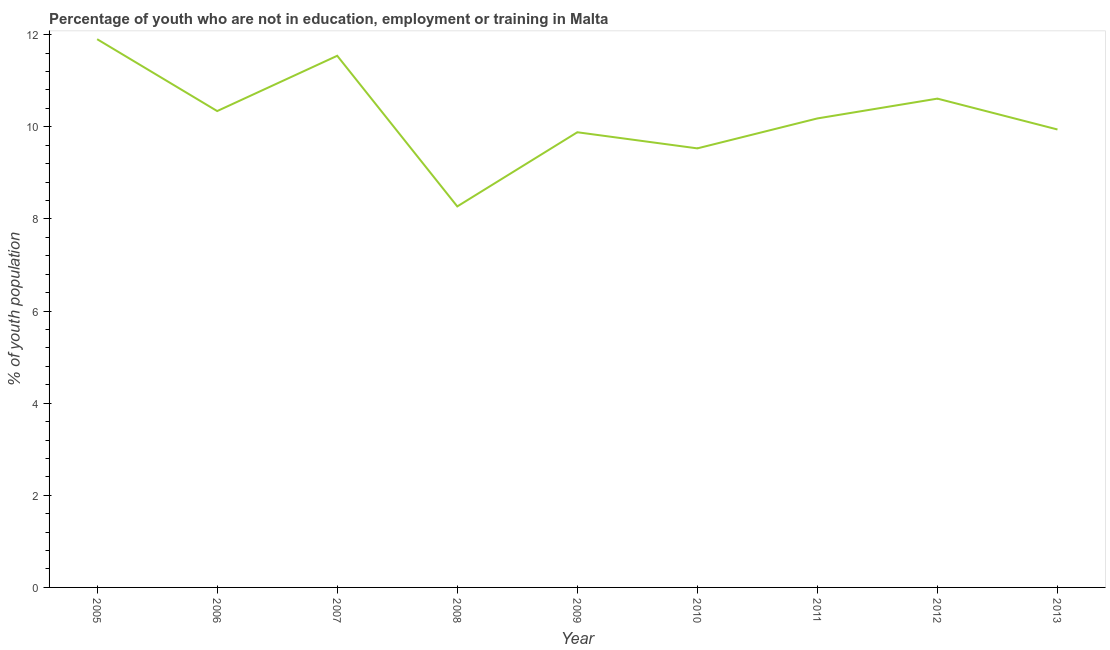What is the unemployed youth population in 2010?
Ensure brevity in your answer.  9.53. Across all years, what is the maximum unemployed youth population?
Your answer should be compact. 11.9. Across all years, what is the minimum unemployed youth population?
Your answer should be compact. 8.27. In which year was the unemployed youth population maximum?
Offer a very short reply. 2005. What is the sum of the unemployed youth population?
Make the answer very short. 92.19. What is the difference between the unemployed youth population in 2006 and 2010?
Provide a short and direct response. 0.81. What is the average unemployed youth population per year?
Your response must be concise. 10.24. What is the median unemployed youth population?
Provide a succinct answer. 10.18. In how many years, is the unemployed youth population greater than 8.8 %?
Your answer should be compact. 8. What is the ratio of the unemployed youth population in 2008 to that in 2013?
Give a very brief answer. 0.83. What is the difference between the highest and the second highest unemployed youth population?
Give a very brief answer. 0.36. Is the sum of the unemployed youth population in 2005 and 2011 greater than the maximum unemployed youth population across all years?
Offer a terse response. Yes. What is the difference between the highest and the lowest unemployed youth population?
Your answer should be compact. 3.63. In how many years, is the unemployed youth population greater than the average unemployed youth population taken over all years?
Provide a succinct answer. 4. Are the values on the major ticks of Y-axis written in scientific E-notation?
Ensure brevity in your answer.  No. Does the graph contain any zero values?
Provide a short and direct response. No. Does the graph contain grids?
Your response must be concise. No. What is the title of the graph?
Your response must be concise. Percentage of youth who are not in education, employment or training in Malta. What is the label or title of the Y-axis?
Your answer should be very brief. % of youth population. What is the % of youth population in 2005?
Provide a short and direct response. 11.9. What is the % of youth population of 2006?
Offer a very short reply. 10.34. What is the % of youth population of 2007?
Ensure brevity in your answer.  11.54. What is the % of youth population of 2008?
Ensure brevity in your answer.  8.27. What is the % of youth population in 2009?
Your answer should be compact. 9.88. What is the % of youth population in 2010?
Give a very brief answer. 9.53. What is the % of youth population of 2011?
Your answer should be compact. 10.18. What is the % of youth population in 2012?
Keep it short and to the point. 10.61. What is the % of youth population in 2013?
Provide a short and direct response. 9.94. What is the difference between the % of youth population in 2005 and 2006?
Keep it short and to the point. 1.56. What is the difference between the % of youth population in 2005 and 2007?
Your answer should be very brief. 0.36. What is the difference between the % of youth population in 2005 and 2008?
Give a very brief answer. 3.63. What is the difference between the % of youth population in 2005 and 2009?
Offer a terse response. 2.02. What is the difference between the % of youth population in 2005 and 2010?
Ensure brevity in your answer.  2.37. What is the difference between the % of youth population in 2005 and 2011?
Offer a very short reply. 1.72. What is the difference between the % of youth population in 2005 and 2012?
Offer a terse response. 1.29. What is the difference between the % of youth population in 2005 and 2013?
Offer a terse response. 1.96. What is the difference between the % of youth population in 2006 and 2007?
Keep it short and to the point. -1.2. What is the difference between the % of youth population in 2006 and 2008?
Give a very brief answer. 2.07. What is the difference between the % of youth population in 2006 and 2009?
Keep it short and to the point. 0.46. What is the difference between the % of youth population in 2006 and 2010?
Offer a terse response. 0.81. What is the difference between the % of youth population in 2006 and 2011?
Offer a terse response. 0.16. What is the difference between the % of youth population in 2006 and 2012?
Give a very brief answer. -0.27. What is the difference between the % of youth population in 2006 and 2013?
Offer a very short reply. 0.4. What is the difference between the % of youth population in 2007 and 2008?
Your response must be concise. 3.27. What is the difference between the % of youth population in 2007 and 2009?
Provide a short and direct response. 1.66. What is the difference between the % of youth population in 2007 and 2010?
Provide a short and direct response. 2.01. What is the difference between the % of youth population in 2007 and 2011?
Your answer should be compact. 1.36. What is the difference between the % of youth population in 2008 and 2009?
Make the answer very short. -1.61. What is the difference between the % of youth population in 2008 and 2010?
Your response must be concise. -1.26. What is the difference between the % of youth population in 2008 and 2011?
Offer a terse response. -1.91. What is the difference between the % of youth population in 2008 and 2012?
Provide a succinct answer. -2.34. What is the difference between the % of youth population in 2008 and 2013?
Your answer should be very brief. -1.67. What is the difference between the % of youth population in 2009 and 2010?
Offer a terse response. 0.35. What is the difference between the % of youth population in 2009 and 2011?
Provide a succinct answer. -0.3. What is the difference between the % of youth population in 2009 and 2012?
Ensure brevity in your answer.  -0.73. What is the difference between the % of youth population in 2009 and 2013?
Ensure brevity in your answer.  -0.06. What is the difference between the % of youth population in 2010 and 2011?
Make the answer very short. -0.65. What is the difference between the % of youth population in 2010 and 2012?
Make the answer very short. -1.08. What is the difference between the % of youth population in 2010 and 2013?
Provide a succinct answer. -0.41. What is the difference between the % of youth population in 2011 and 2012?
Keep it short and to the point. -0.43. What is the difference between the % of youth population in 2011 and 2013?
Your answer should be very brief. 0.24. What is the difference between the % of youth population in 2012 and 2013?
Provide a short and direct response. 0.67. What is the ratio of the % of youth population in 2005 to that in 2006?
Offer a very short reply. 1.15. What is the ratio of the % of youth population in 2005 to that in 2007?
Your response must be concise. 1.03. What is the ratio of the % of youth population in 2005 to that in 2008?
Provide a succinct answer. 1.44. What is the ratio of the % of youth population in 2005 to that in 2009?
Offer a terse response. 1.2. What is the ratio of the % of youth population in 2005 to that in 2010?
Provide a short and direct response. 1.25. What is the ratio of the % of youth population in 2005 to that in 2011?
Your answer should be very brief. 1.17. What is the ratio of the % of youth population in 2005 to that in 2012?
Ensure brevity in your answer.  1.12. What is the ratio of the % of youth population in 2005 to that in 2013?
Offer a terse response. 1.2. What is the ratio of the % of youth population in 2006 to that in 2007?
Keep it short and to the point. 0.9. What is the ratio of the % of youth population in 2006 to that in 2009?
Make the answer very short. 1.05. What is the ratio of the % of youth population in 2006 to that in 2010?
Make the answer very short. 1.08. What is the ratio of the % of youth population in 2006 to that in 2011?
Offer a very short reply. 1.02. What is the ratio of the % of youth population in 2006 to that in 2012?
Provide a succinct answer. 0.97. What is the ratio of the % of youth population in 2006 to that in 2013?
Your answer should be compact. 1.04. What is the ratio of the % of youth population in 2007 to that in 2008?
Your answer should be compact. 1.4. What is the ratio of the % of youth population in 2007 to that in 2009?
Your answer should be compact. 1.17. What is the ratio of the % of youth population in 2007 to that in 2010?
Offer a very short reply. 1.21. What is the ratio of the % of youth population in 2007 to that in 2011?
Provide a succinct answer. 1.13. What is the ratio of the % of youth population in 2007 to that in 2012?
Offer a very short reply. 1.09. What is the ratio of the % of youth population in 2007 to that in 2013?
Give a very brief answer. 1.16. What is the ratio of the % of youth population in 2008 to that in 2009?
Make the answer very short. 0.84. What is the ratio of the % of youth population in 2008 to that in 2010?
Provide a short and direct response. 0.87. What is the ratio of the % of youth population in 2008 to that in 2011?
Keep it short and to the point. 0.81. What is the ratio of the % of youth population in 2008 to that in 2012?
Offer a terse response. 0.78. What is the ratio of the % of youth population in 2008 to that in 2013?
Offer a very short reply. 0.83. What is the ratio of the % of youth population in 2009 to that in 2010?
Offer a very short reply. 1.04. What is the ratio of the % of youth population in 2010 to that in 2011?
Your answer should be compact. 0.94. What is the ratio of the % of youth population in 2010 to that in 2012?
Offer a terse response. 0.9. What is the ratio of the % of youth population in 2010 to that in 2013?
Your response must be concise. 0.96. What is the ratio of the % of youth population in 2011 to that in 2013?
Give a very brief answer. 1.02. What is the ratio of the % of youth population in 2012 to that in 2013?
Give a very brief answer. 1.07. 